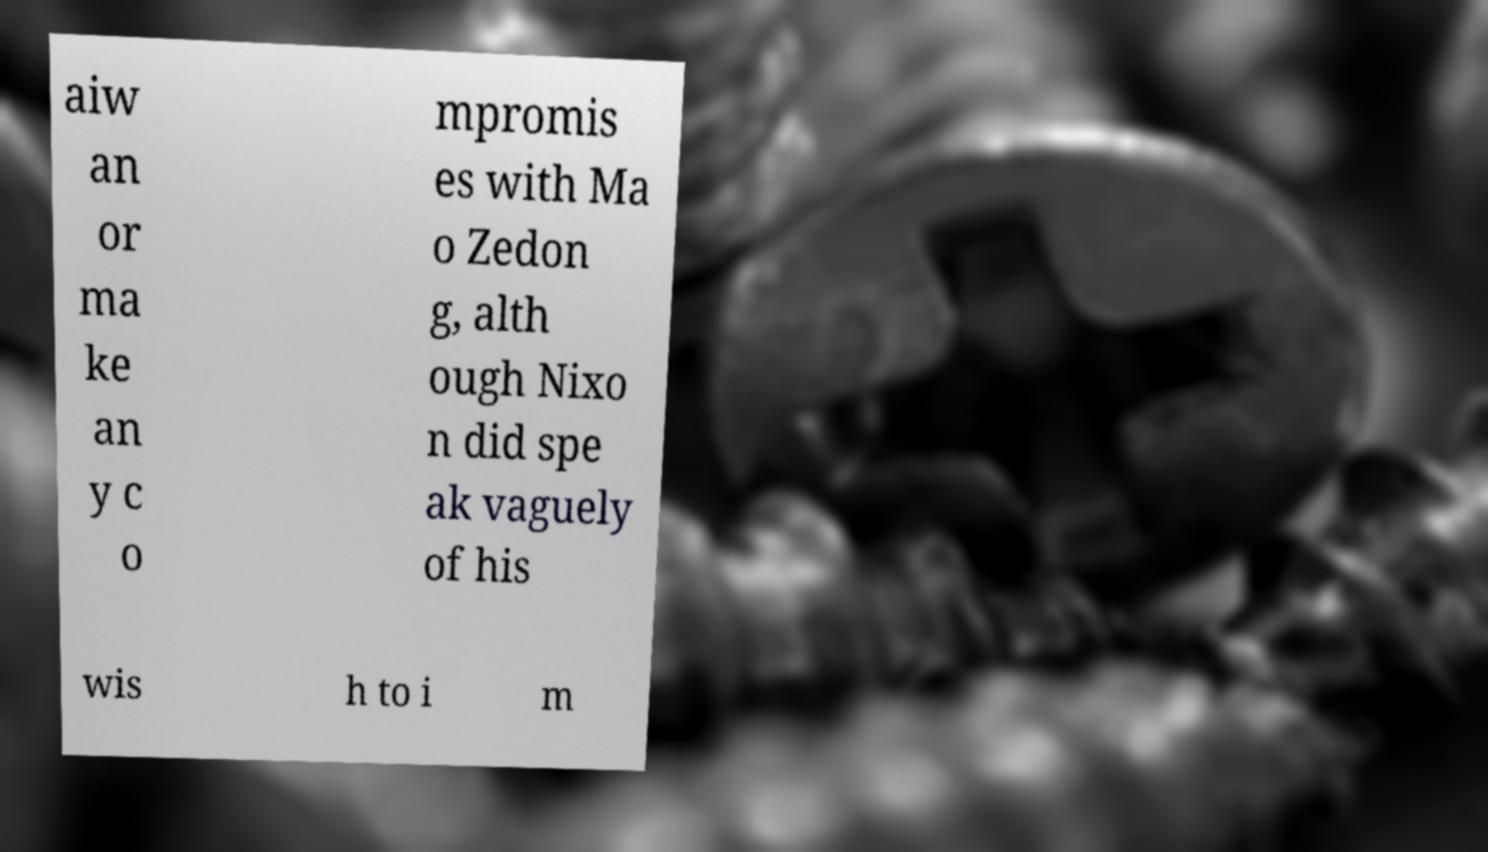Can you read and provide the text displayed in the image?This photo seems to have some interesting text. Can you extract and type it out for me? aiw an or ma ke an y c o mpromis es with Ma o Zedon g, alth ough Nixo n did spe ak vaguely of his wis h to i m 